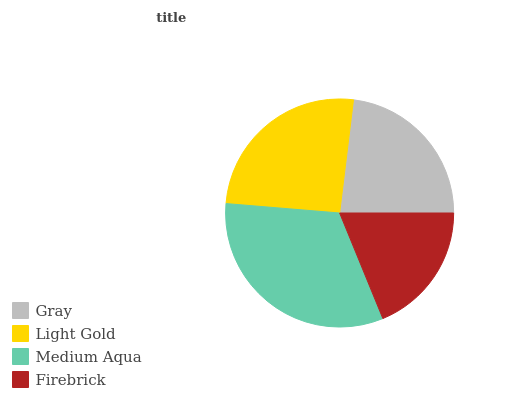Is Firebrick the minimum?
Answer yes or no. Yes. Is Medium Aqua the maximum?
Answer yes or no. Yes. Is Light Gold the minimum?
Answer yes or no. No. Is Light Gold the maximum?
Answer yes or no. No. Is Light Gold greater than Gray?
Answer yes or no. Yes. Is Gray less than Light Gold?
Answer yes or no. Yes. Is Gray greater than Light Gold?
Answer yes or no. No. Is Light Gold less than Gray?
Answer yes or no. No. Is Light Gold the high median?
Answer yes or no. Yes. Is Gray the low median?
Answer yes or no. Yes. Is Medium Aqua the high median?
Answer yes or no. No. Is Light Gold the low median?
Answer yes or no. No. 